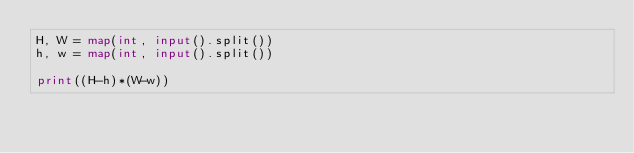Convert code to text. <code><loc_0><loc_0><loc_500><loc_500><_Python_>H, W = map(int, input().split())
h, w = map(int, input().split())

print((H-h)*(W-w))</code> 